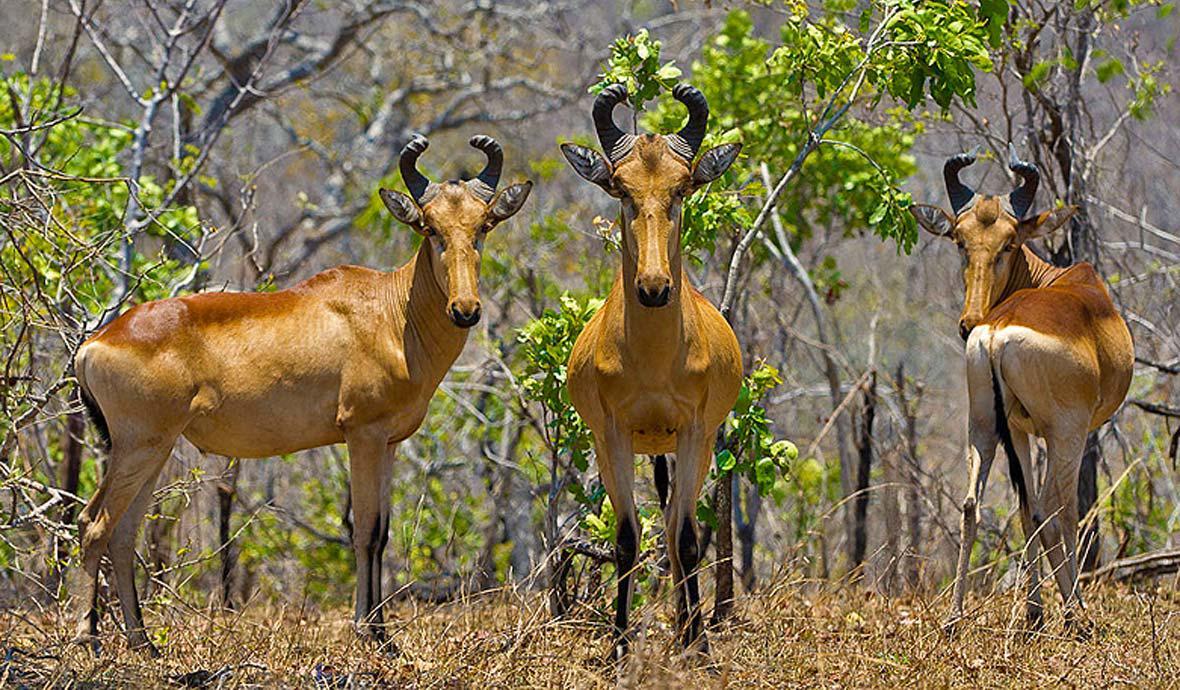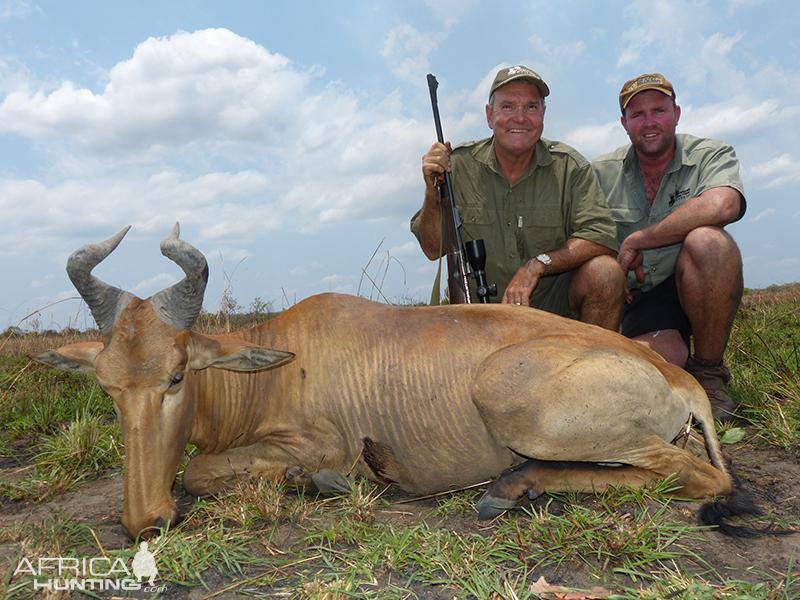The first image is the image on the left, the second image is the image on the right. For the images shown, is this caption "One of the images contains one man with a dead antelope." true? Answer yes or no. No. The first image is the image on the left, the second image is the image on the right. Examine the images to the left and right. Is the description "Just one hunter crouches behind a downed antelope in one of the images." accurate? Answer yes or no. No. 